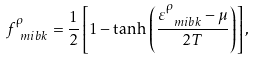<formula> <loc_0><loc_0><loc_500><loc_500>f _ { \ m i b { k } } ^ { \rho } = \frac { 1 } { 2 } \left [ 1 - \tanh \left ( \frac { \varepsilon _ { \ m i b { k } } ^ { \rho } - \mu } { 2 T } \right ) \right ] ,</formula> 